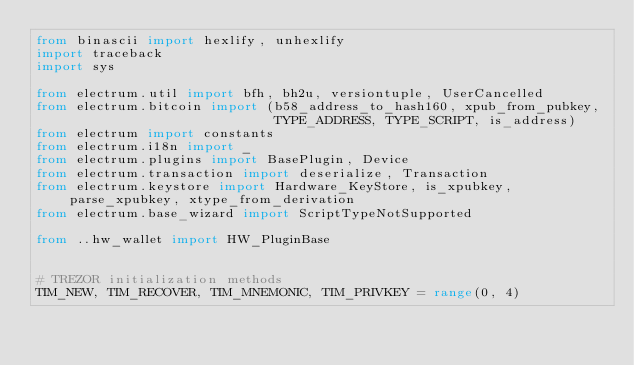<code> <loc_0><loc_0><loc_500><loc_500><_Python_>from binascii import hexlify, unhexlify
import traceback
import sys

from electrum.util import bfh, bh2u, versiontuple, UserCancelled
from electrum.bitcoin import (b58_address_to_hash160, xpub_from_pubkey,
                              TYPE_ADDRESS, TYPE_SCRIPT, is_address)
from electrum import constants
from electrum.i18n import _
from electrum.plugins import BasePlugin, Device
from electrum.transaction import deserialize, Transaction
from electrum.keystore import Hardware_KeyStore, is_xpubkey, parse_xpubkey, xtype_from_derivation
from electrum.base_wizard import ScriptTypeNotSupported

from ..hw_wallet import HW_PluginBase


# TREZOR initialization methods
TIM_NEW, TIM_RECOVER, TIM_MNEMONIC, TIM_PRIVKEY = range(0, 4)</code> 